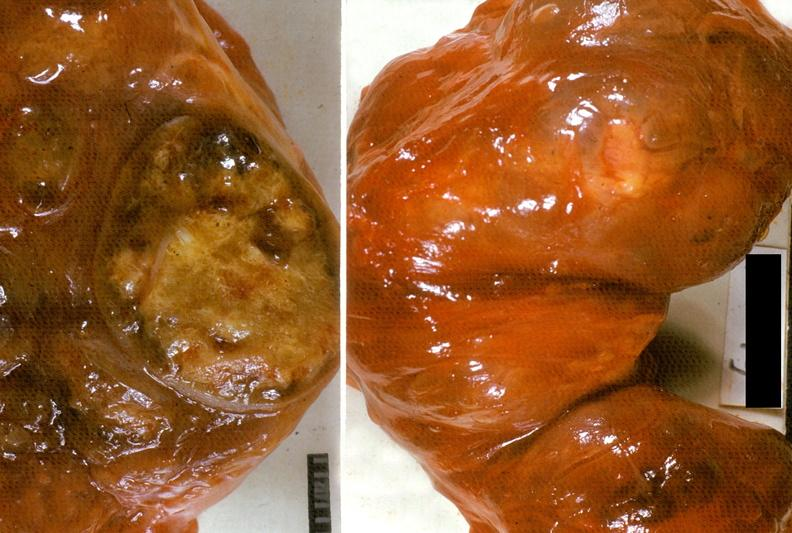what is present?
Answer the question using a single word or phrase. Endocrine 